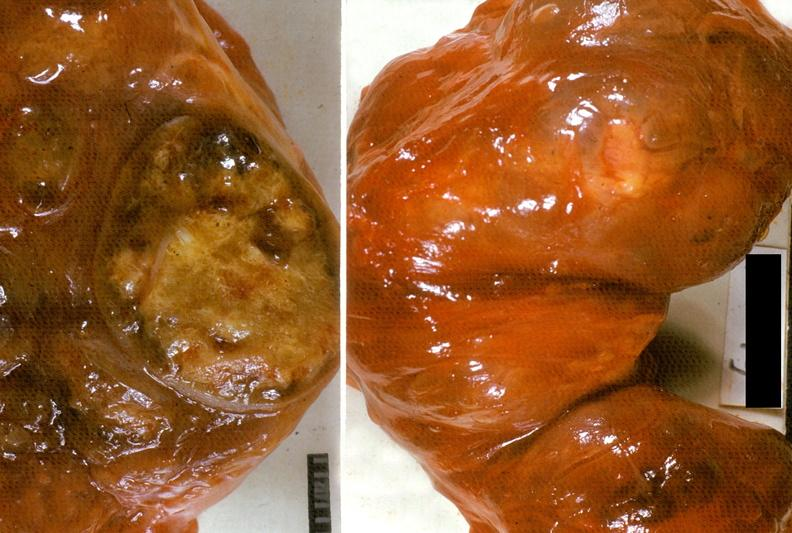what is present?
Answer the question using a single word or phrase. Endocrine 